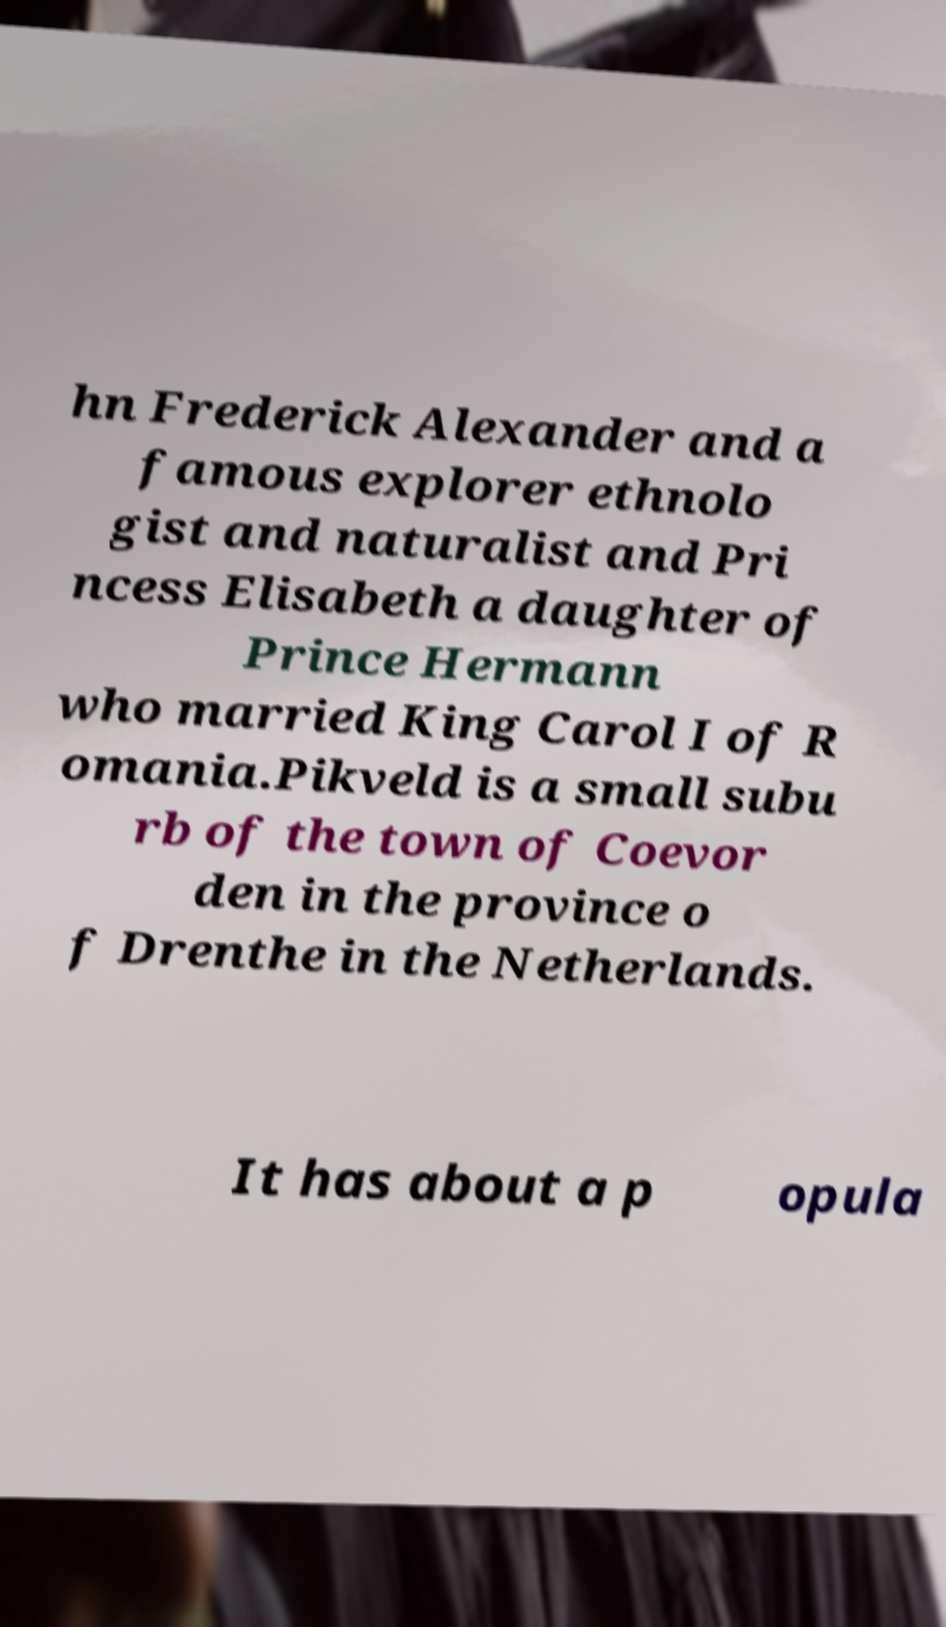What messages or text are displayed in this image? I need them in a readable, typed format. hn Frederick Alexander and a famous explorer ethnolo gist and naturalist and Pri ncess Elisabeth a daughter of Prince Hermann who married King Carol I of R omania.Pikveld is a small subu rb of the town of Coevor den in the province o f Drenthe in the Netherlands. It has about a p opula 